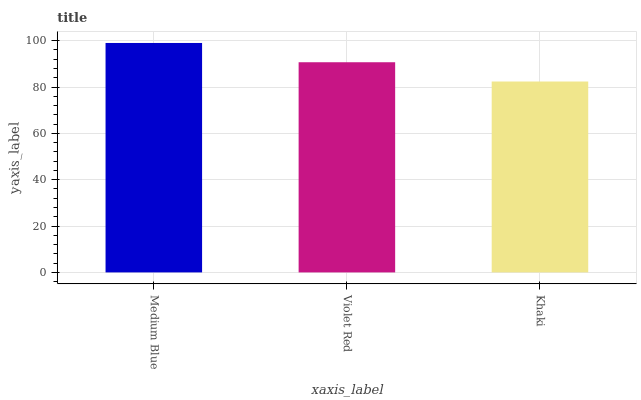Is Khaki the minimum?
Answer yes or no. Yes. Is Medium Blue the maximum?
Answer yes or no. Yes. Is Violet Red the minimum?
Answer yes or no. No. Is Violet Red the maximum?
Answer yes or no. No. Is Medium Blue greater than Violet Red?
Answer yes or no. Yes. Is Violet Red less than Medium Blue?
Answer yes or no. Yes. Is Violet Red greater than Medium Blue?
Answer yes or no. No. Is Medium Blue less than Violet Red?
Answer yes or no. No. Is Violet Red the high median?
Answer yes or no. Yes. Is Violet Red the low median?
Answer yes or no. Yes. Is Khaki the high median?
Answer yes or no. No. Is Medium Blue the low median?
Answer yes or no. No. 